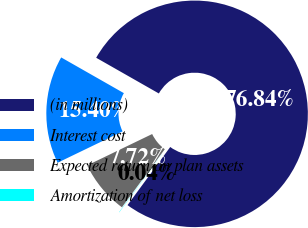<chart> <loc_0><loc_0><loc_500><loc_500><pie_chart><fcel>(in millions)<fcel>Interest cost<fcel>Expected return on plan assets<fcel>Amortization of net loss<nl><fcel>76.84%<fcel>15.4%<fcel>7.72%<fcel>0.04%<nl></chart> 